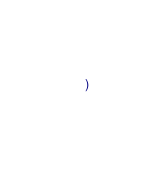<code> <loc_0><loc_0><loc_500><loc_500><_Scheme_>  )
</code> 